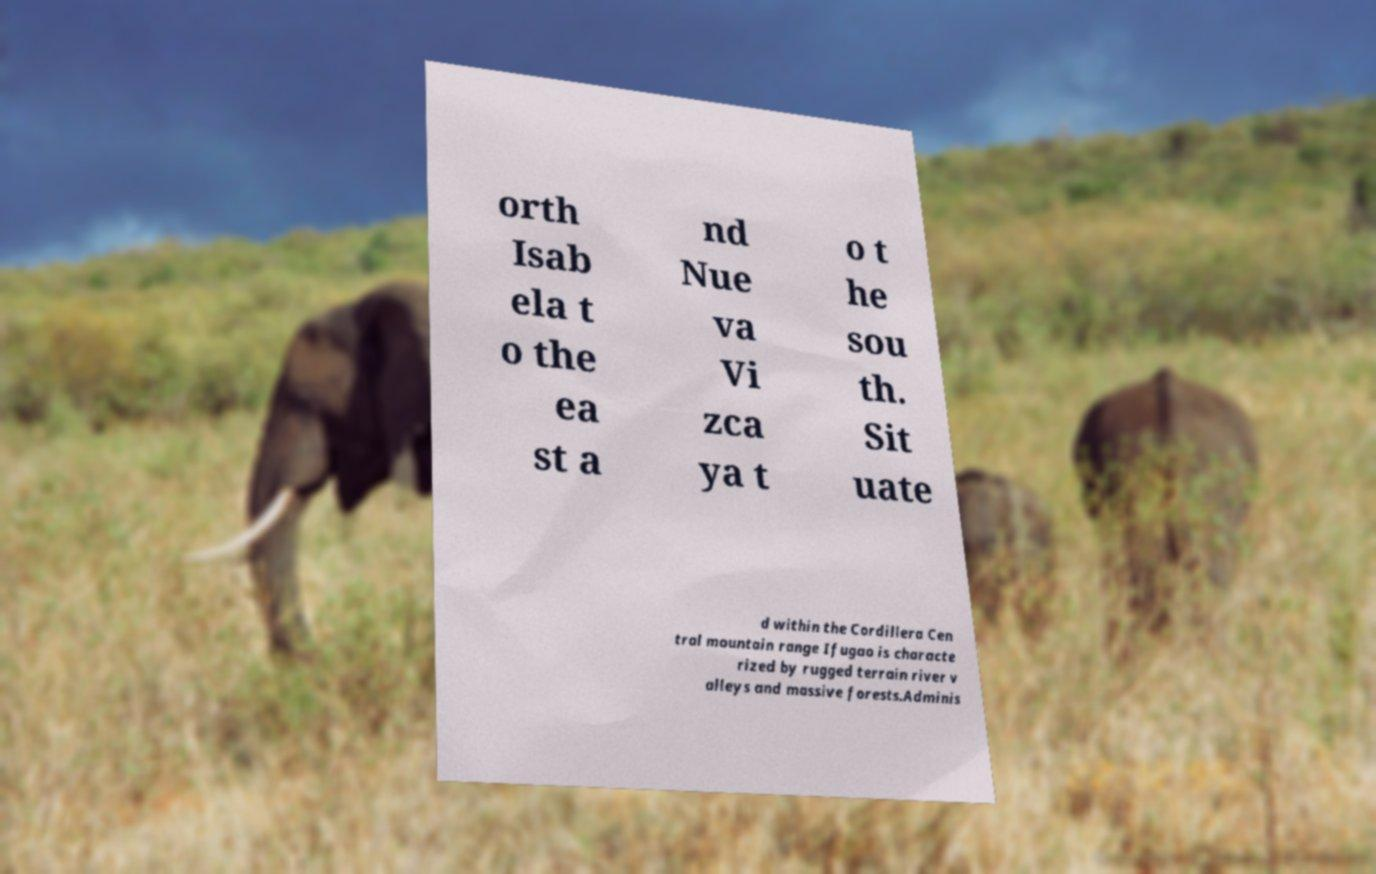Can you read and provide the text displayed in the image?This photo seems to have some interesting text. Can you extract and type it out for me? orth Isab ela t o the ea st a nd Nue va Vi zca ya t o t he sou th. Sit uate d within the Cordillera Cen tral mountain range Ifugao is characte rized by rugged terrain river v alleys and massive forests.Adminis 